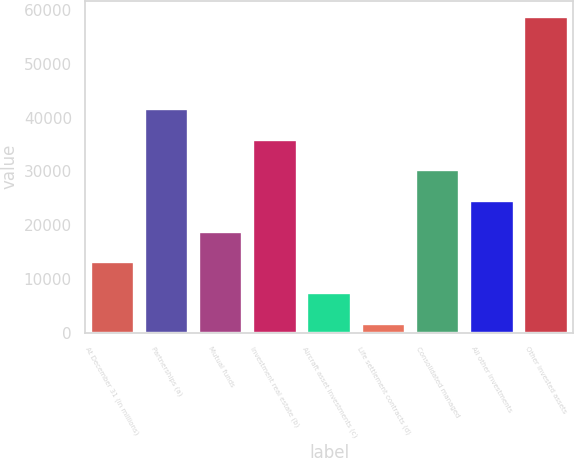<chart> <loc_0><loc_0><loc_500><loc_500><bar_chart><fcel>At December 31 (in millions)<fcel>Partnerships (a)<fcel>Mutual funds<fcel>Investment real estate (b)<fcel>Aircraft asset investments (c)<fcel>Life settlement contracts (d)<fcel>Consolidated managed<fcel>All other investments<fcel>Other invested assets<nl><fcel>13066.2<fcel>41664.2<fcel>18785.8<fcel>35944.6<fcel>7346.6<fcel>1627<fcel>30225<fcel>24505.4<fcel>58823<nl></chart> 